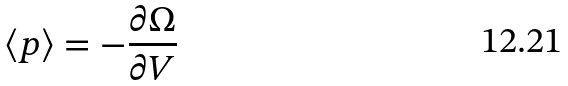<formula> <loc_0><loc_0><loc_500><loc_500>\langle p \rangle = - \frac { \partial \Omega } { \partial V }</formula> 